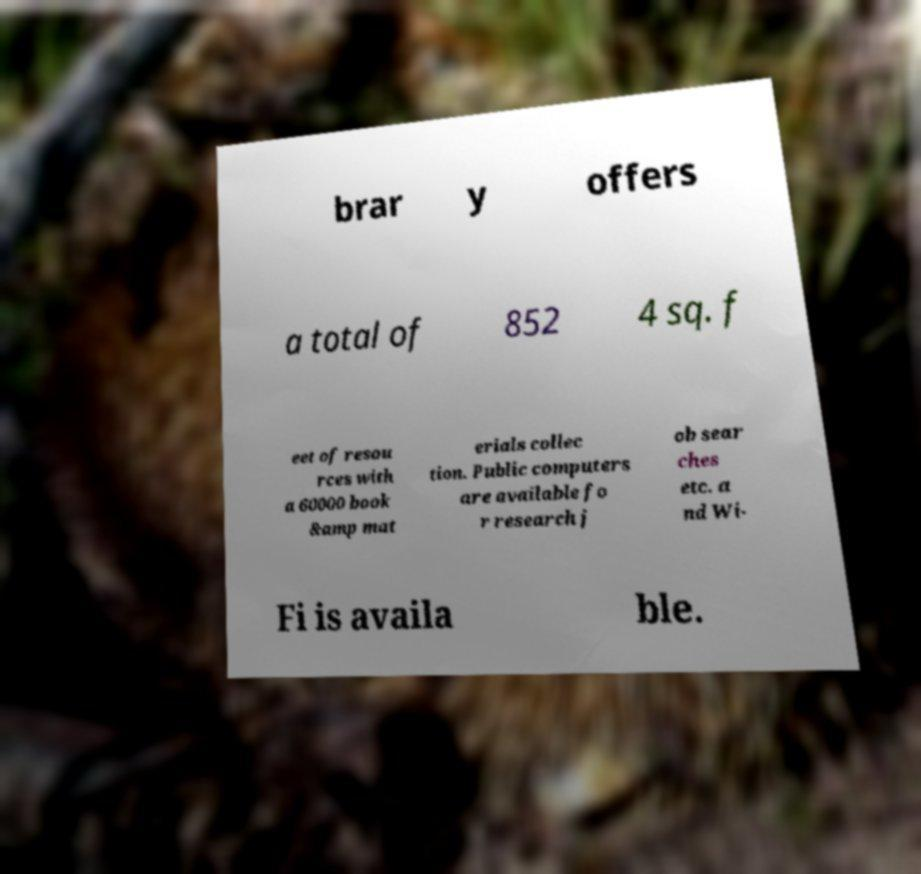There's text embedded in this image that I need extracted. Can you transcribe it verbatim? brar y offers a total of 852 4 sq. f eet of resou rces with a 60000 book &amp mat erials collec tion. Public computers are available fo r research j ob sear ches etc. a nd Wi- Fi is availa ble. 